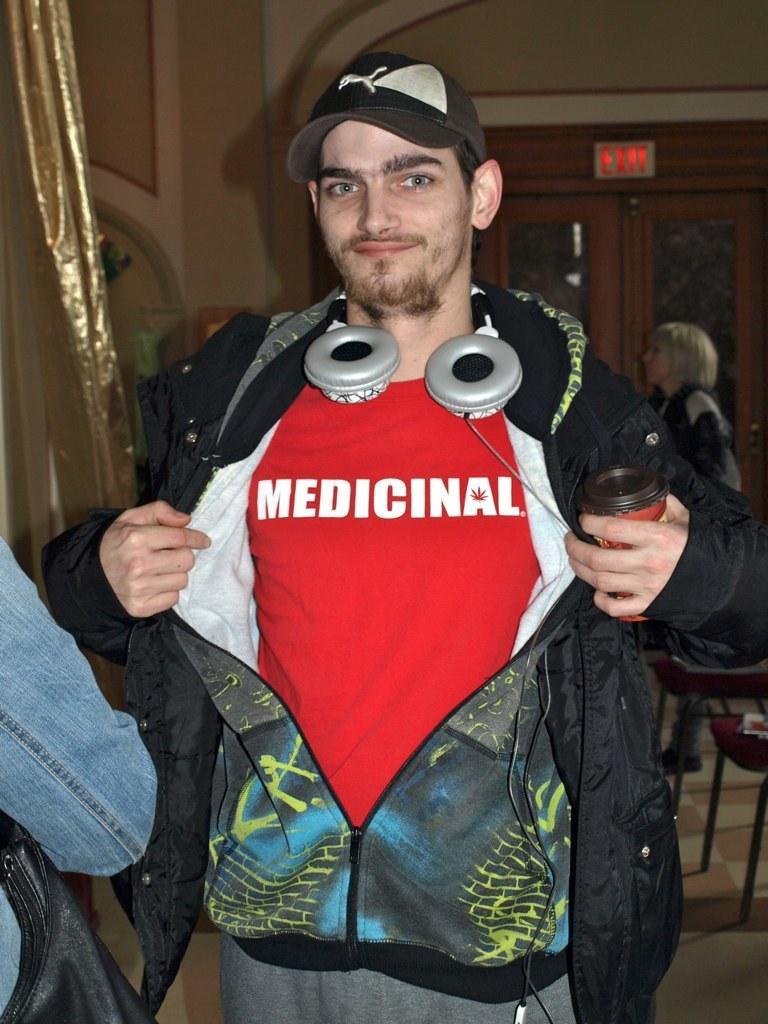Describe this image in one or two sentences. In this image I can see a person standing wearing red shirt, black jacket, black cap. At the back I can see few persons standing, at left I can see a curtain in gold color. 